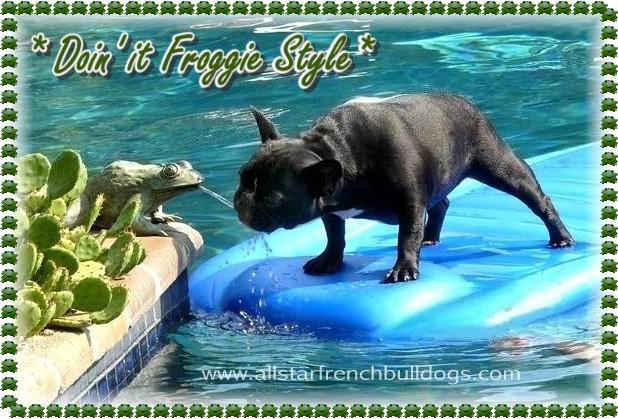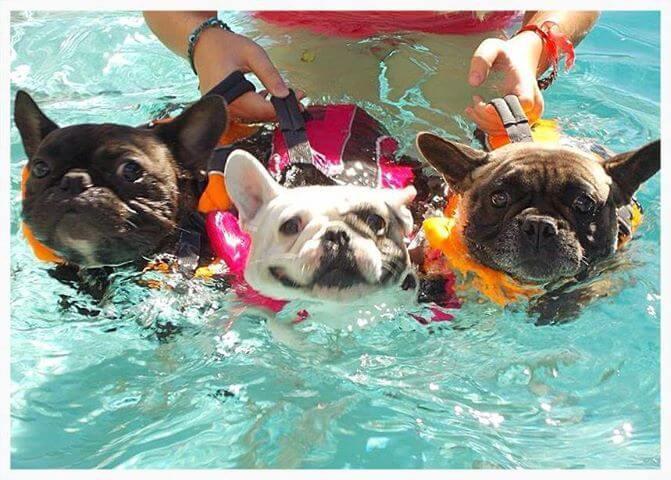The first image is the image on the left, the second image is the image on the right. For the images shown, is this caption "Each image contains one dog in a swimming pool, and the right image shows a bulldog swimming at a leftward angle and wearing an orange life vest." true? Answer yes or no. No. The first image is the image on the left, the second image is the image on the right. Examine the images to the left and right. Is the description "One of the images shows a dog floating in a pool while using an inner tube." accurate? Answer yes or no. No. 